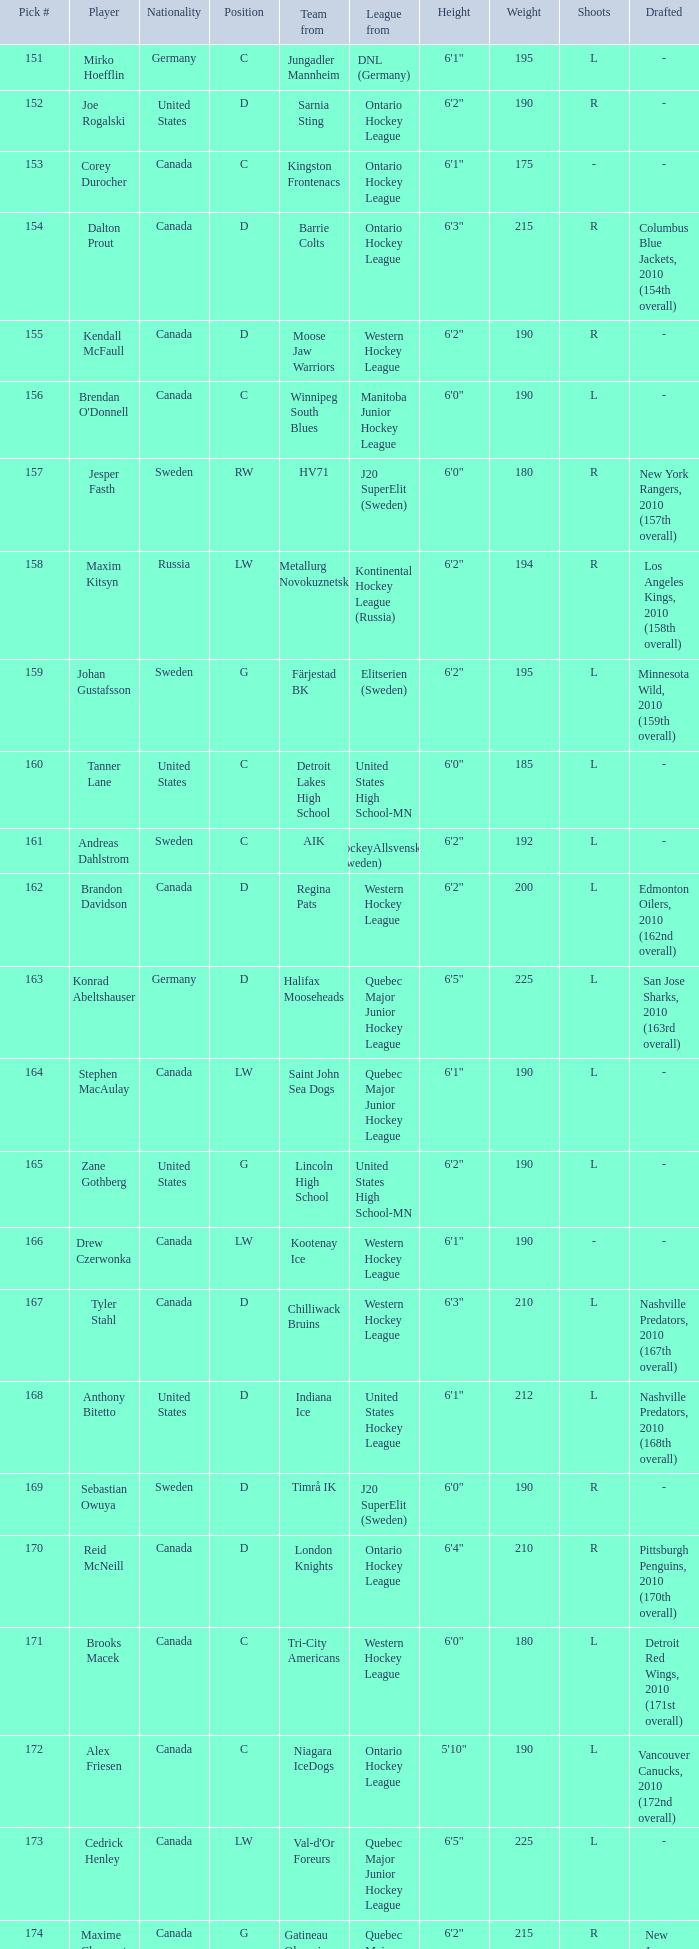What is the league that has the pick #160? United States High School-MN. Parse the table in full. {'header': ['Pick #', 'Player', 'Nationality', 'Position', 'Team from', 'League from', 'Height', 'Weight', 'Shoots', 'Drafted'], 'rows': [['151', 'Mirko Hoefflin', 'Germany', 'C', 'Jungadler Mannheim', 'DNL (Germany)', '6\'1"', '195', 'L', '-'], ['152', 'Joe Rogalski', 'United States', 'D', 'Sarnia Sting', 'Ontario Hockey League', '6\'2"', '190', 'R', '-'], ['153', 'Corey Durocher', 'Canada', 'C', 'Kingston Frontenacs', 'Ontario Hockey League', '6\'1"', '175', '-', '-'], ['154', 'Dalton Prout', 'Canada', 'D', 'Barrie Colts', 'Ontario Hockey League', '6\'3"', '215', 'R', 'Columbus Blue Jackets, 2010 (154th overall)'], ['155', 'Kendall McFaull', 'Canada', 'D', 'Moose Jaw Warriors', 'Western Hockey League', '6\'2"', '190', 'R', '-'], ['156', "Brendan O'Donnell", 'Canada', 'C', 'Winnipeg South Blues', 'Manitoba Junior Hockey League', '6\'0"', '190', 'L', '-'], ['157', 'Jesper Fasth', 'Sweden', 'RW', 'HV71', 'J20 SuperElit (Sweden)', '6\'0"', '180', 'R', 'New York Rangers, 2010 (157th overall)'], ['158', 'Maxim Kitsyn', 'Russia', 'LW', 'Metallurg Novokuznetsk', 'Kontinental Hockey League (Russia)', '6\'2"', '194', 'R', 'Los Angeles Kings, 2010 (158th overall)'], ['159', 'Johan Gustafsson', 'Sweden', 'G', 'Färjestad BK', 'Elitserien (Sweden)', '6\'2"', '195', 'L', 'Minnesota Wild, 2010 (159th overall)'], ['160', 'Tanner Lane', 'United States', 'C', 'Detroit Lakes High School', 'United States High School-MN', '6\'0"', '185', 'L', '-'], ['161', 'Andreas Dahlstrom', 'Sweden', 'C', 'AIK', 'HockeyAllsvenskan (Sweden)', '6\'2"', '192', 'L', '-'], ['162', 'Brandon Davidson', 'Canada', 'D', 'Regina Pats', 'Western Hockey League', '6\'2"', '200', 'L', 'Edmonton Oilers, 2010 (162nd overall)'], ['163', 'Konrad Abeltshauser', 'Germany', 'D', 'Halifax Mooseheads', 'Quebec Major Junior Hockey League', '6\'5"', '225', 'L', 'San Jose Sharks, 2010 (163rd overall)'], ['164', 'Stephen MacAulay', 'Canada', 'LW', 'Saint John Sea Dogs', 'Quebec Major Junior Hockey League', '6\'1"', '190', 'L', '-'], ['165', 'Zane Gothberg', 'United States', 'G', 'Lincoln High School', 'United States High School-MN', '6\'2"', '190', 'L', '-'], ['166', 'Drew Czerwonka', 'Canada', 'LW', 'Kootenay Ice', 'Western Hockey League', '6\'1"', '190', '-', '-'], ['167', 'Tyler Stahl', 'Canada', 'D', 'Chilliwack Bruins', 'Western Hockey League', '6\'3"', '210', 'L', 'Nashville Predators, 2010 (167th overall)'], ['168', 'Anthony Bitetto', 'United States', 'D', 'Indiana Ice', 'United States Hockey League', '6\'1"', '212', 'L', 'Nashville Predators, 2010 (168th overall)'], ['169', 'Sebastian Owuya', 'Sweden', 'D', 'Timrå IK', 'J20 SuperElit (Sweden)', '6\'0"', '190', 'R', '-'], ['170', 'Reid McNeill', 'Canada', 'D', 'London Knights', 'Ontario Hockey League', '6\'4"', '210', 'R', 'Pittsburgh Penguins, 2010 (170th overall)'], ['171', 'Brooks Macek', 'Canada', 'C', 'Tri-City Americans', 'Western Hockey League', '6\'0"', '180', 'L', 'Detroit Red Wings, 2010 (171st overall)'], ['172', 'Alex Friesen', 'Canada', 'C', 'Niagara IceDogs', 'Ontario Hockey League', '5\'10"', '190', 'L', 'Vancouver Canucks, 2010 (172nd overall)'], ['173', 'Cedrick Henley', 'Canada', 'LW', "Val-d'Or Foreurs", 'Quebec Major Junior Hockey League', '6\'5"', '225', 'L', '-'], ['174', 'Maxime Clermont', 'Canada', 'G', 'Gatineau Olympiques', 'Quebec Major Junior Hockey League', '6\'2"', '215', 'R', 'New Jersey Devils, 2010 (174th overall)'], ['175', 'Jonathan Iilahti', 'Finland', 'G', 'Espoo Blues', 'SM-liiga Jr. (Finland)', '5\'11"', '165', 'L', '-'], ['176', 'Samuel Carrier', 'Canada', 'RW', 'Lewiston Maineiacs', 'Quebec Major Junior Hockey League', '6\'2"', '198', 'R', '-'], ['177', 'Kevin Lind', 'United States', 'D', 'Chicago Steel', 'United States Hockey League', '6\'2"', '189', 'L', 'Anaheim Ducks, 2010 (177th overall)'], ['178', 'Mark Stone', 'Canada', 'RW', 'Brandon Wheat Kings', 'Western Hockey League', '6\'4"', '219', 'R', 'Ottawa Senators, 2010 (178th overall)'], ['179', 'Nicholas Luukko', 'United States', 'D', 'The Gunnery', 'United States High School-CT', '6\'2"', '200', 'R', 'Philadelphia Flyers, 2010 (179th overall)'], ['180', 'Nick Mattson', 'United States', 'D', 'Indiana Ice', 'United States Hockey League', '6\'1"', '173', 'L', 'Chicago Blackhawks, 2010 (180th overall)']]} 